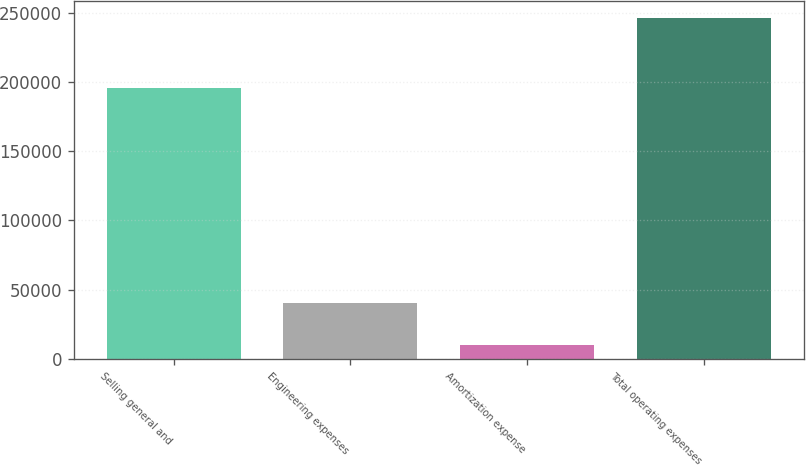Convert chart. <chart><loc_0><loc_0><loc_500><loc_500><bar_chart><fcel>Selling general and<fcel>Engineering expenses<fcel>Amortization expense<fcel>Total operating expenses<nl><fcel>195892<fcel>40203<fcel>10173<fcel>246268<nl></chart> 